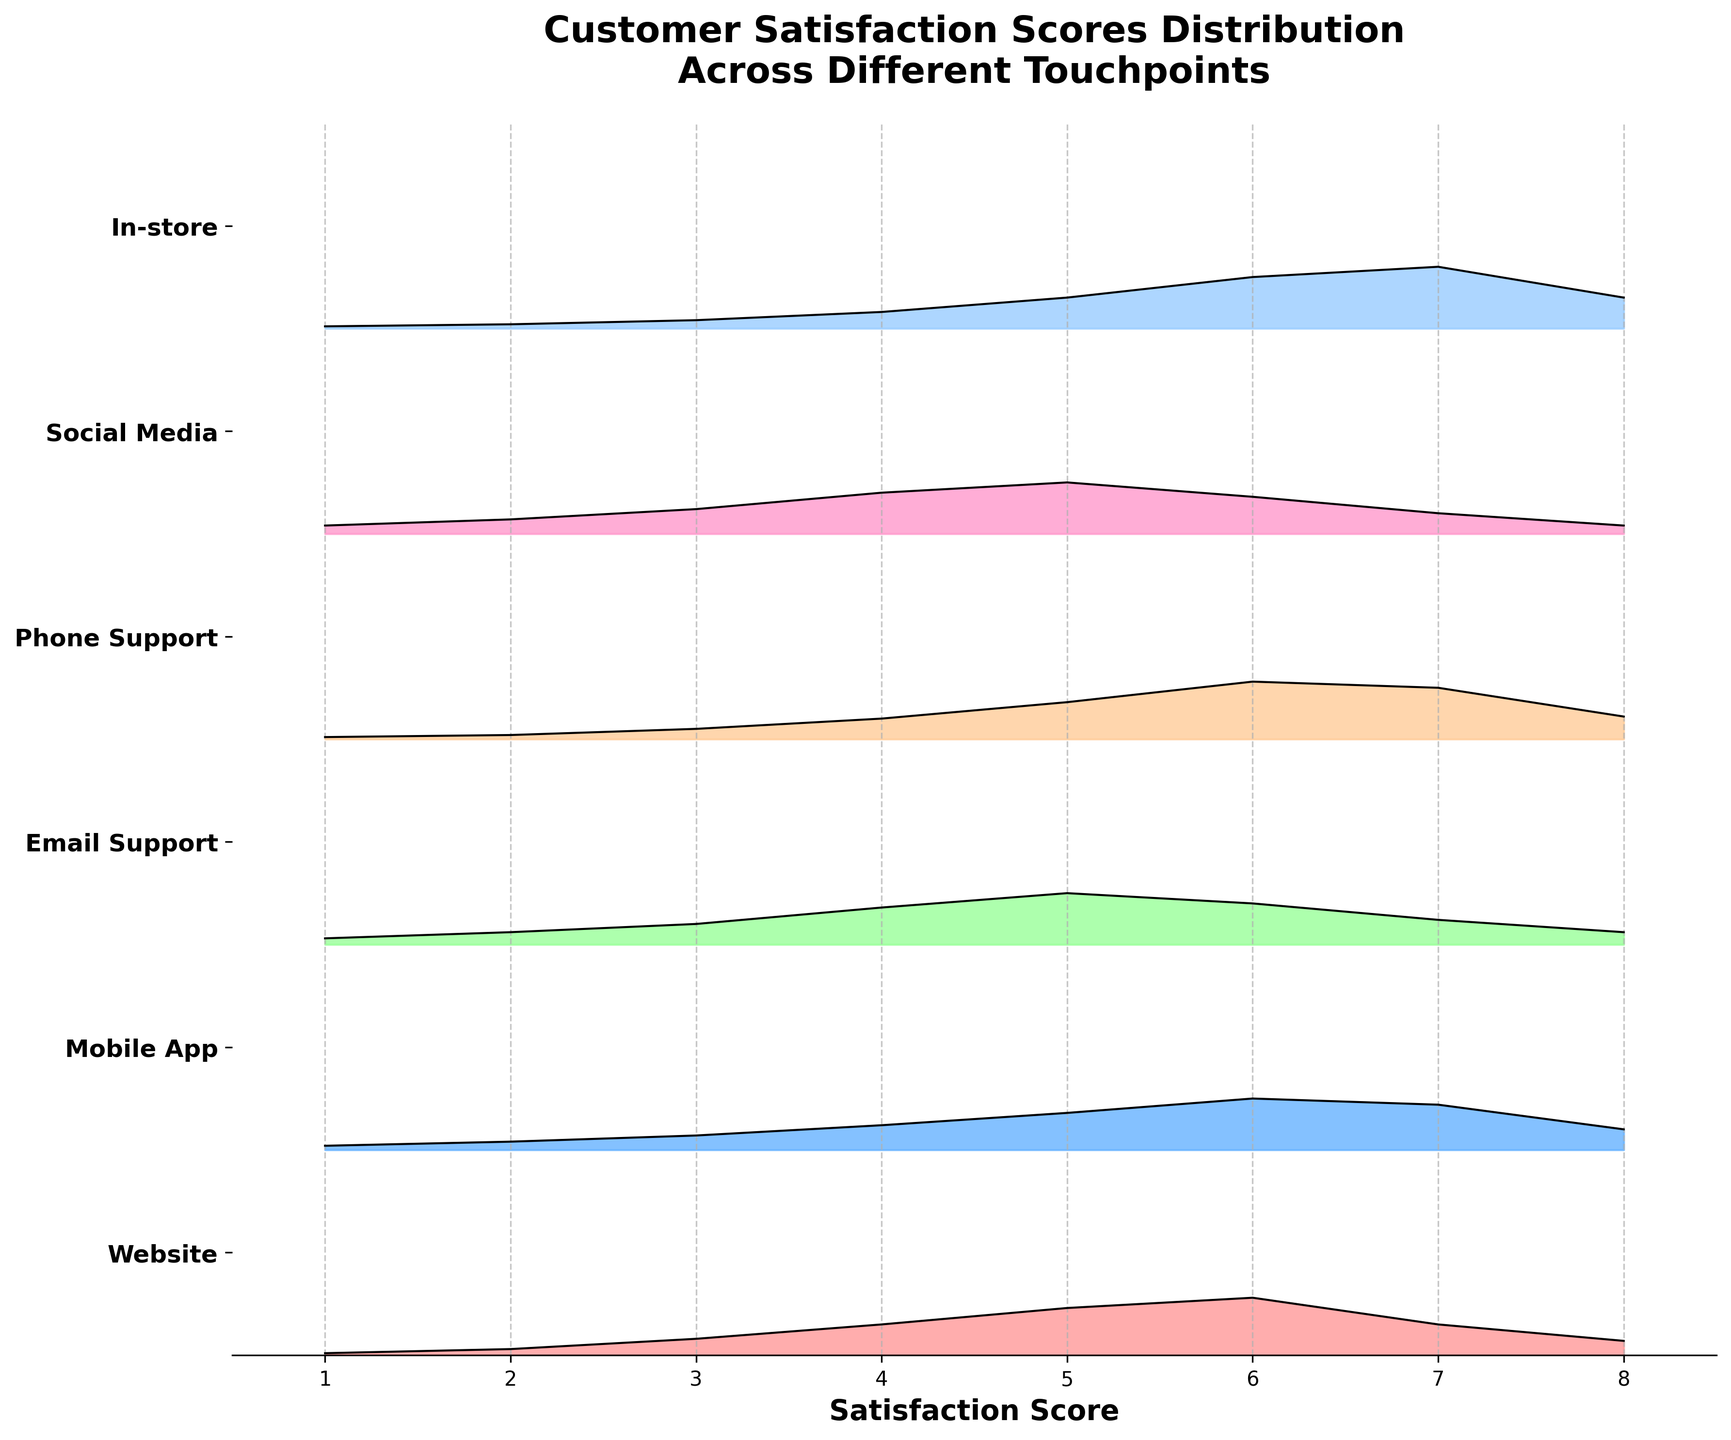What's the title of the figure? The title is displayed at the top of the figure and states the main subject of the visualization, which is the distribution of customer satisfaction scores across different touchpoints in the customer journey.
Answer: Customer Satisfaction Scores Distribution Across Different Touchpoints What does the x-axis represent? The x-axis of the figure is labeled and indicates the range of satisfaction scores, which are numerical values from 1 to 8.
Answer: Satisfaction Score How many touchpoints are shown in the figure? The y-axis lists all the touchpoints. By counting the items on the y-axis, we can determine that there are six touchpoints: Website, Mobile App, Email Support, Phone Support, Social Media, and In-store.
Answer: Six Which touchpoint has the highest density for a satisfaction score of 6? By observing the height of the peak at the satisfaction score of 6 for each touchpoint, we can identify the one with the highest value. The In-store touchpoint has the highest peak.
Answer: In-store What is the shape of the distribution for the Website touchpoint? We examine the fill between the lines on the ridgeline for the Website touchpoint. The shape shows an initial rise, peaking around a score of 6, and then tapering off towards higher scores.
Answer: Peaks at 6, then tapers off How do the highest density scores for Email Support and Phone Support touchpoints compare? By looking at the highest points of the ridgelines for both Email Support and Phone Support, we notice that the highest density for Email Support is at score 5, while for Phone Support, it is at score 6.
Answer: Email Support peaks at 5; Phone Support peaks at 6 Which touchpoint has the broadest distribution of satisfaction scores? We assess the width of the ridgeline plots for each touchpoint. The Social Media touchpoint has a relatively wide distribution covering almost all satisfaction scores.
Answer: Social Media What is the median satisfaction score for the In-store touchpoint? To find the median, we identify the score at which 50% of the density lies on either side. The median for In-store appears to be around a score of 6, where the distribution significantly peaks.
Answer: Approximately 6 At which touchpoint are the lower satisfaction scores (1 to 3) more dense? Comparing the densities at lower satisfaction scores (1 to 3) for each touchpoint, Social Media has relatively higher densities in those regions.
Answer: Social Media How do the densities for the highest satisfaction score (8) compare across touchpoints? By comparing the values at a satisfaction score of 8 for each touchpoint, it's evident that the densities diminish quite similarly across all touchpoints, with none showing significantly higher values for that score.
Answer: Densities at 8 are low across all touchpoints 